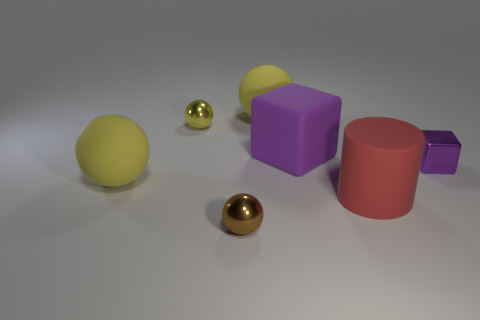Do the metal cube and the red matte object have the same size?
Keep it short and to the point. No. What size is the matte cube that is the same color as the tiny shiny cube?
Ensure brevity in your answer.  Large. How many rubber objects are the same color as the metallic block?
Give a very brief answer. 1. What is the color of the big matte sphere that is behind the small purple metallic cube?
Make the answer very short. Yellow. There is another matte thing that is the same shape as the small purple thing; what is its size?
Give a very brief answer. Large. How many things are yellow objects that are behind the large cube or tiny things behind the large rubber cube?
Your answer should be very brief. 2. There is a rubber object that is in front of the big cube and behind the large matte cylinder; what size is it?
Provide a succinct answer. Large. Does the brown metallic thing have the same shape as the small metallic thing that is on the right side of the brown metal sphere?
Provide a succinct answer. No. How many objects are either tiny metallic objects that are in front of the big red rubber object or tiny gray matte cubes?
Your answer should be compact. 1. Does the small purple thing have the same material as the tiny thing that is left of the tiny brown shiny object?
Ensure brevity in your answer.  Yes. 